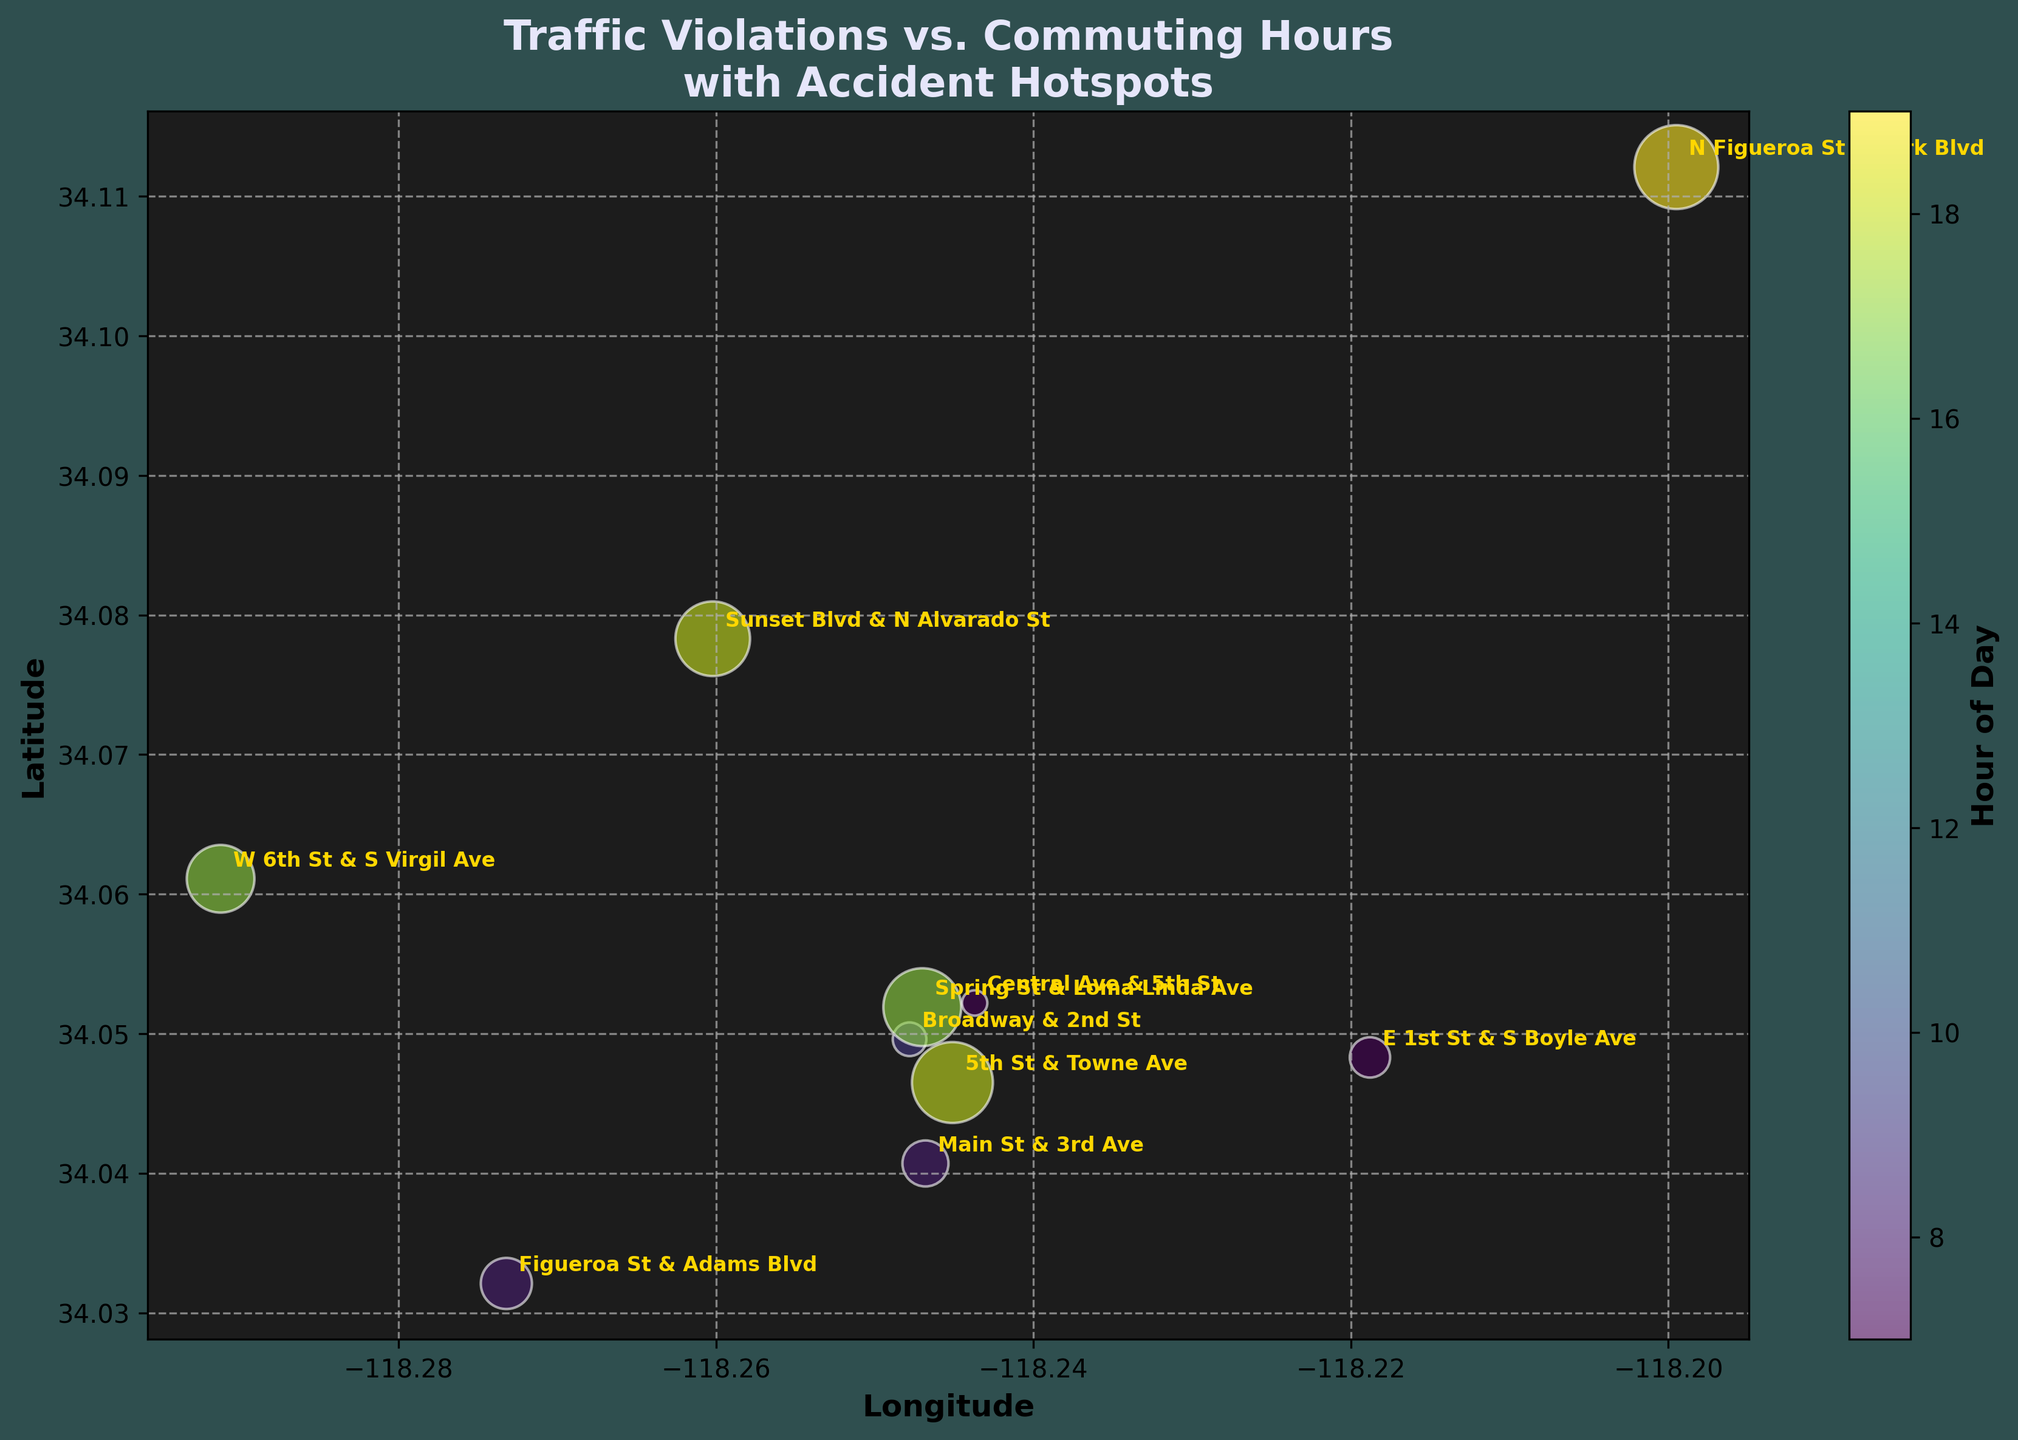What is the title of the bubble chart? The title is displayed at the top of the chart and reads: "Traffic Violations vs. Commuting Hours with Accident Hotspots."
Answer: Traffic Violations vs. Commuting Hours with Accident Hotspots How many data points are plotted on the chart? By counting the bubbles on the chart, there are 10 distinct data points represented.
Answer: 10 Which element on the chart is the largest bubble and can you identify its corresponding data point? The largest bubble represents the highest violation count, which is 250, located at N Figueroa St & York Blvd.
Answer: N Figueroa St & York Blvd What does the color of the bubbles represent? The color of the bubbles represents the hour of the day when the traffic violations occurred, ranging from morning to evening.
Answer: Hour of the day Which hotspot has the highest violation count and what time did it occur? The highest violation count is 250, occurring at 19:00 (7 PM) at N Figueroa St & York Blvd.
Answer: N Figueroa St & York Blvd, 19:00 At what time do the two hotspots with the second-largest violation counts occur? The second-largest violation counts are 240 and 230, occurring at 18:00 (5th St & Towne Ave) and 17:00 (Spring St & Loma Linda Ave), respectively.
Answer: 18:00 and 17:00 Which hotspot is labeled on the chart for the hour of 8 AM? Checking the bubble color corresponding to 8 AM, the labeled hotspot is Main St & 3rd Ave.
Answer: Main St & 3rd Ave How do the sizes of the bubbles relate to the traffic violation counts? Larger bubbles correspond to higher violation counts, while smaller bubbles indicate lower violation counts. Bubble size is proportional to the number of violations.
Answer: Proportional to violation counts Which two hotspots are closest to each other on the map in terms of their geographical coordinates? By visually comparing the coordinates, Central Ave & 5th St and Main St & 3rd Ave appear closest in proximity on the map.
Answer: Central Ave & 5th St and Main St & 3rd Ave What is the range of hours represented in the chart for the occurrence of traffic violations? The chart encompasses hours starting from 7 AM to 7 PM, as indicated by the color scale and annotations.
Answer: 7 AM to 7 PM 